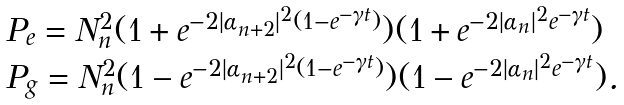Convert formula to latex. <formula><loc_0><loc_0><loc_500><loc_500>\begin{array} { l } P _ { e } = N _ { n } ^ { 2 } ( 1 + e ^ { - 2 | \alpha _ { n + 2 } | ^ { 2 } ( 1 - e ^ { - \gamma t } ) } ) ( 1 + e ^ { - 2 | \alpha _ { n } | ^ { 2 } e ^ { - \gamma t } } ) \\ P _ { g } = N _ { n } ^ { 2 } ( 1 - e ^ { - 2 | \alpha _ { n + 2 } | ^ { 2 } ( 1 - e ^ { - \gamma t } ) } ) ( 1 - e ^ { - 2 | \alpha _ { n } | ^ { 2 } e ^ { - \gamma t } } ) . \end{array}</formula> 